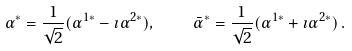Convert formula to latex. <formula><loc_0><loc_0><loc_500><loc_500>\alpha ^ { * } = \frac { 1 } { \sqrt { 2 } } ( \alpha ^ { 1 * } - \imath \alpha ^ { 2 * } ) , \quad \bar { \alpha } ^ { * } = \frac { 1 } { \sqrt { 2 } } ( \alpha ^ { 1 * } + \imath \alpha ^ { 2 * } ) \, .</formula> 